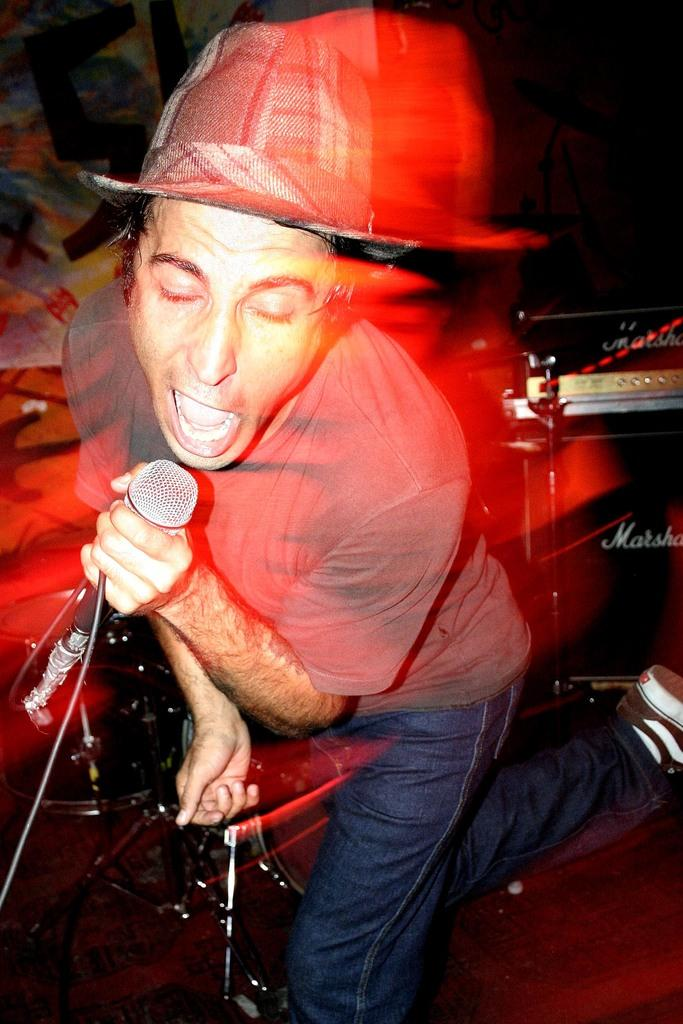Who is the main subject in the image? There is a man in the image. Where is the man located in the image? The man is standing in the middle of the image. What is the man holding in the image? The man is holding a microphone. What can be said about the color of the microphone? The microphone is black in color. What is the man doing with the microphone? The man is singing into the microphone. Can you tell me how many boys are present in the image? There is no boy present in the image; it features a man holding a microphone. What type of zebra can be seen in the image? There is no zebra present in the image. 